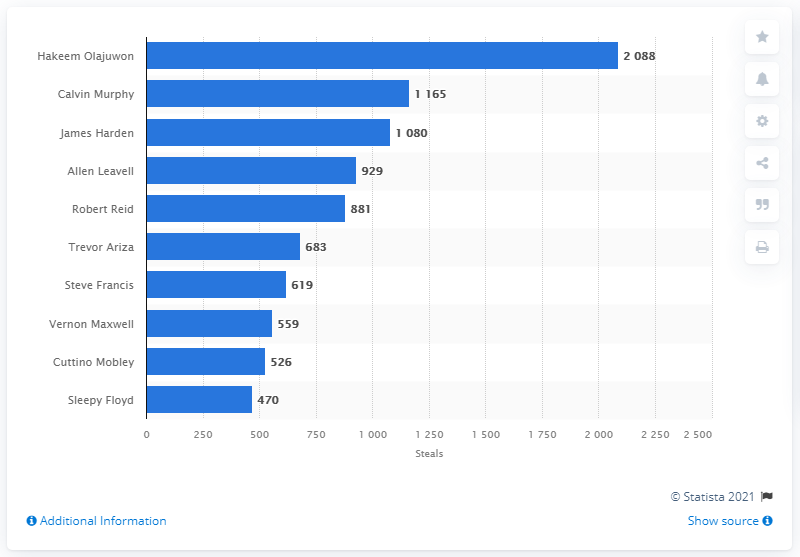List a handful of essential elements in this visual. The career steals leader of the Houston Rockets is Hakeem Olajuwon. 